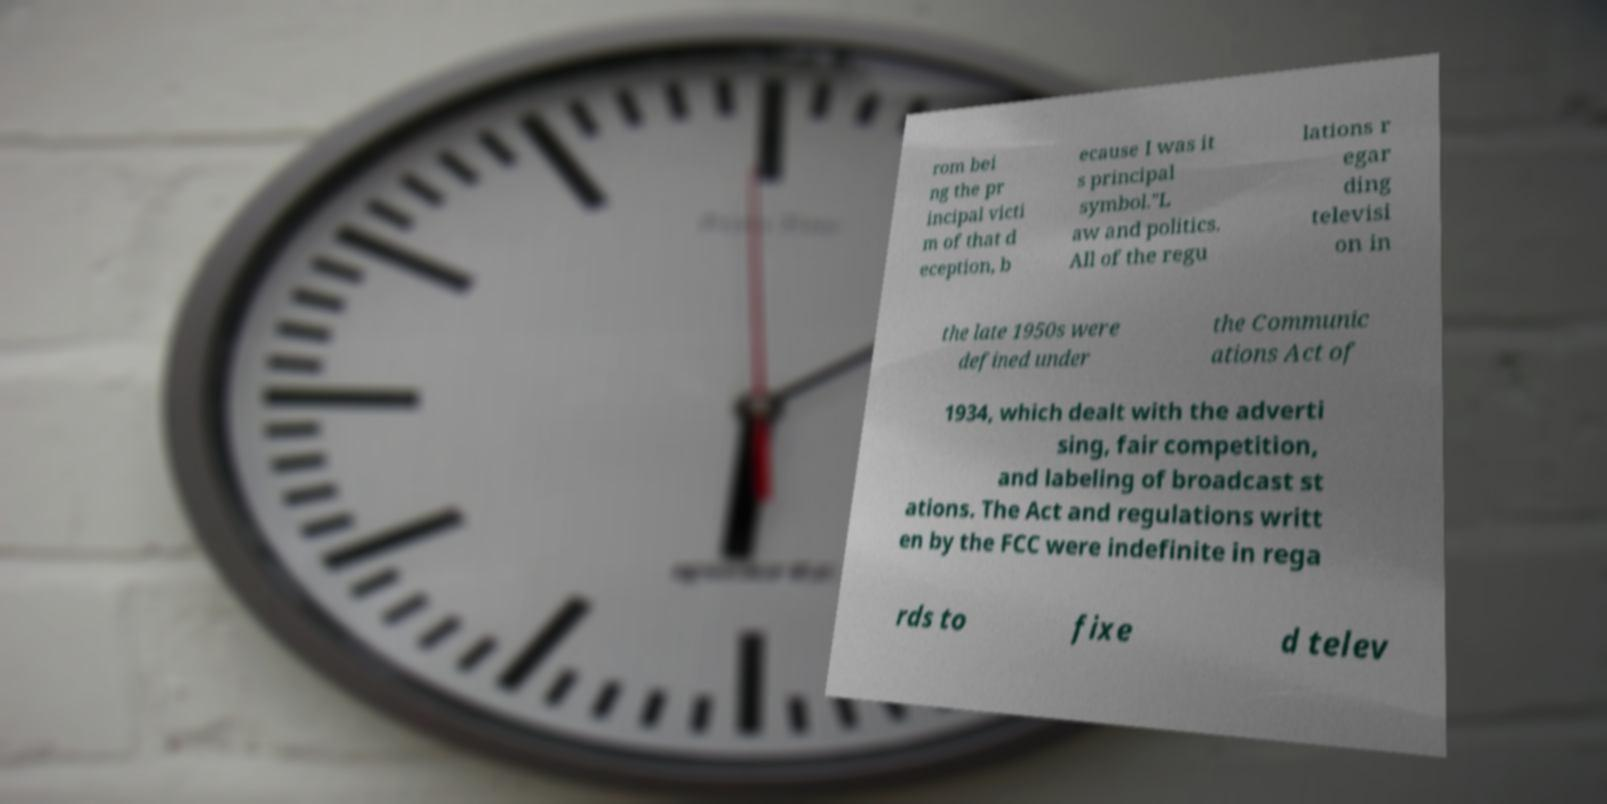I need the written content from this picture converted into text. Can you do that? rom bei ng the pr incipal victi m of that d eception, b ecause I was it s principal symbol."L aw and politics. All of the regu lations r egar ding televisi on in the late 1950s were defined under the Communic ations Act of 1934, which dealt with the adverti sing, fair competition, and labeling of broadcast st ations. The Act and regulations writt en by the FCC were indefinite in rega rds to fixe d telev 